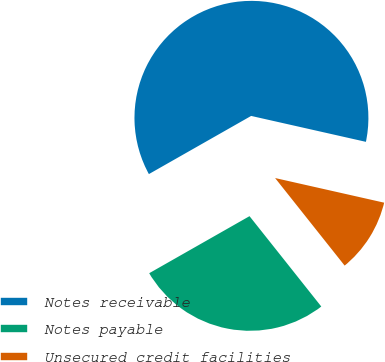<chart> <loc_0><loc_0><loc_500><loc_500><pie_chart><fcel>Notes receivable<fcel>Notes payable<fcel>Unsecured credit facilities<nl><fcel>61.76%<fcel>27.45%<fcel>10.78%<nl></chart> 